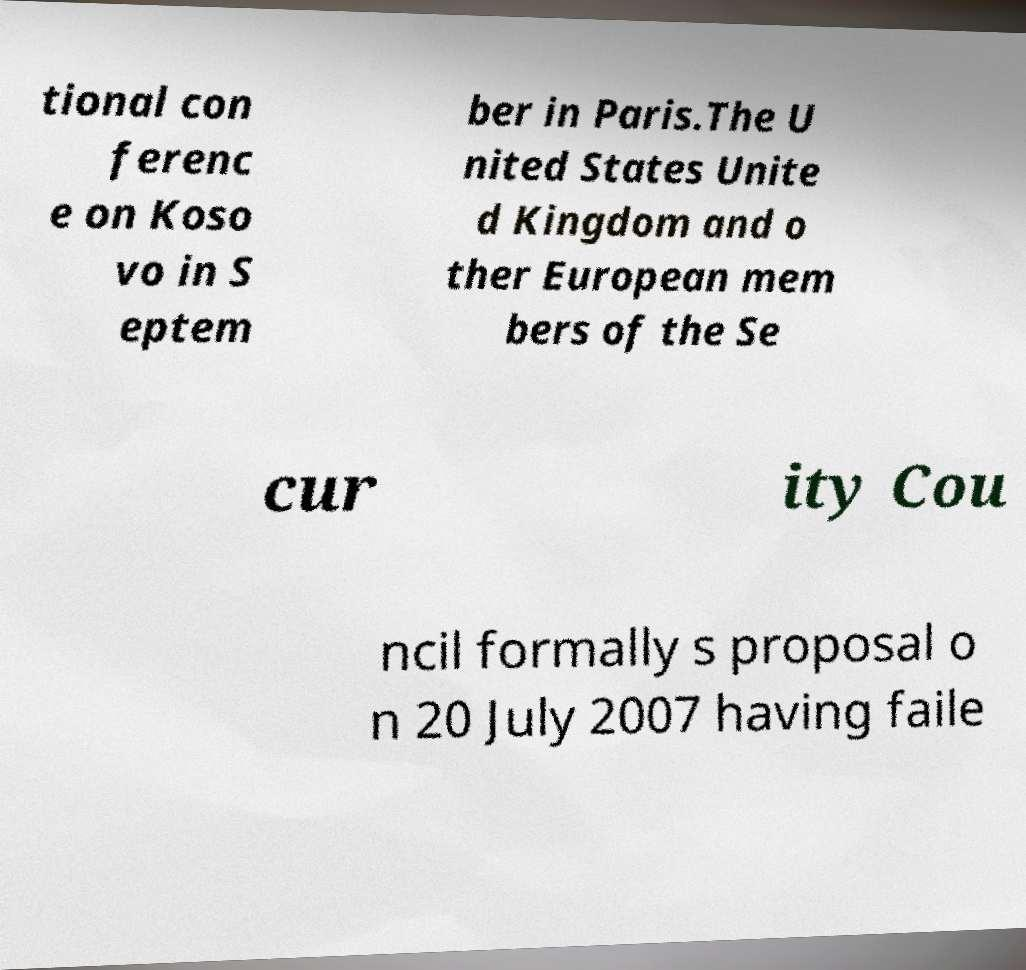There's text embedded in this image that I need extracted. Can you transcribe it verbatim? tional con ferenc e on Koso vo in S eptem ber in Paris.The U nited States Unite d Kingdom and o ther European mem bers of the Se cur ity Cou ncil formally s proposal o n 20 July 2007 having faile 